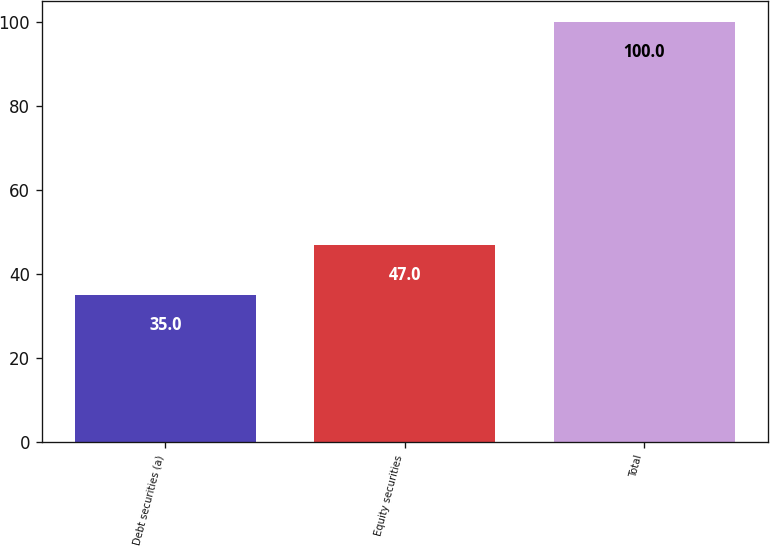Convert chart to OTSL. <chart><loc_0><loc_0><loc_500><loc_500><bar_chart><fcel>Debt securities (a)<fcel>Equity securities<fcel>Total<nl><fcel>35<fcel>47<fcel>100<nl></chart> 